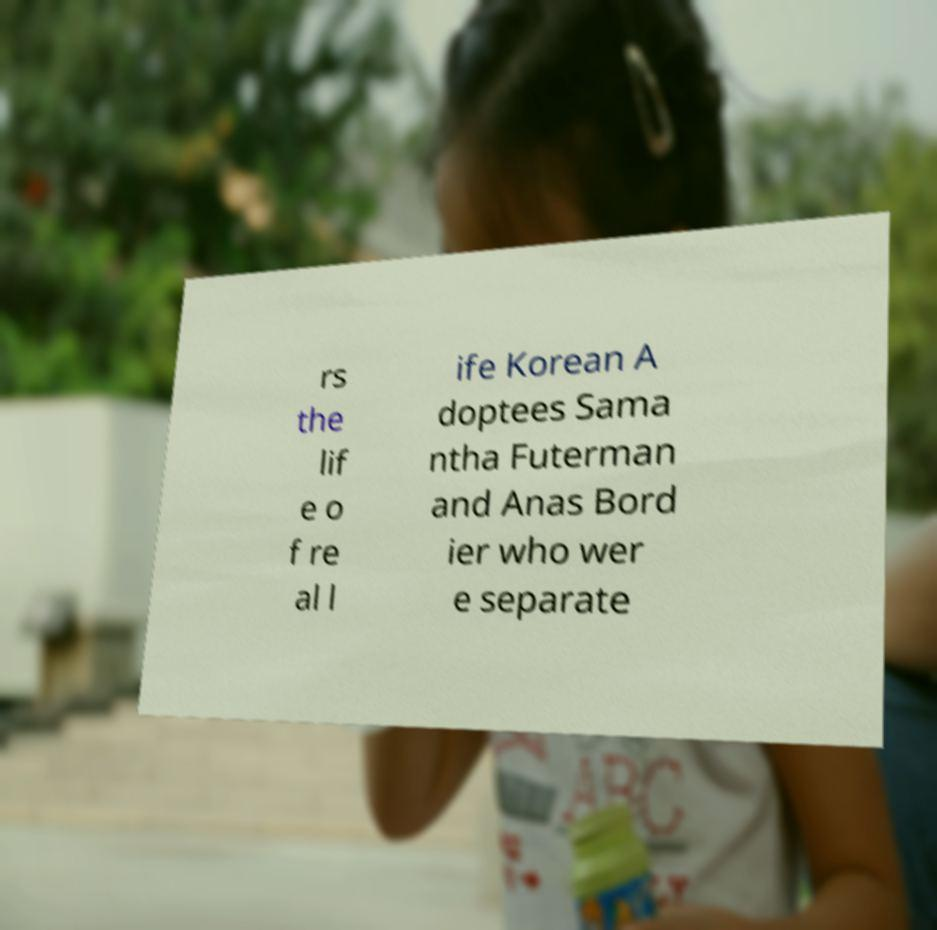What messages or text are displayed in this image? I need them in a readable, typed format. rs the lif e o f re al l ife Korean A doptees Sama ntha Futerman and Anas Bord ier who wer e separate 